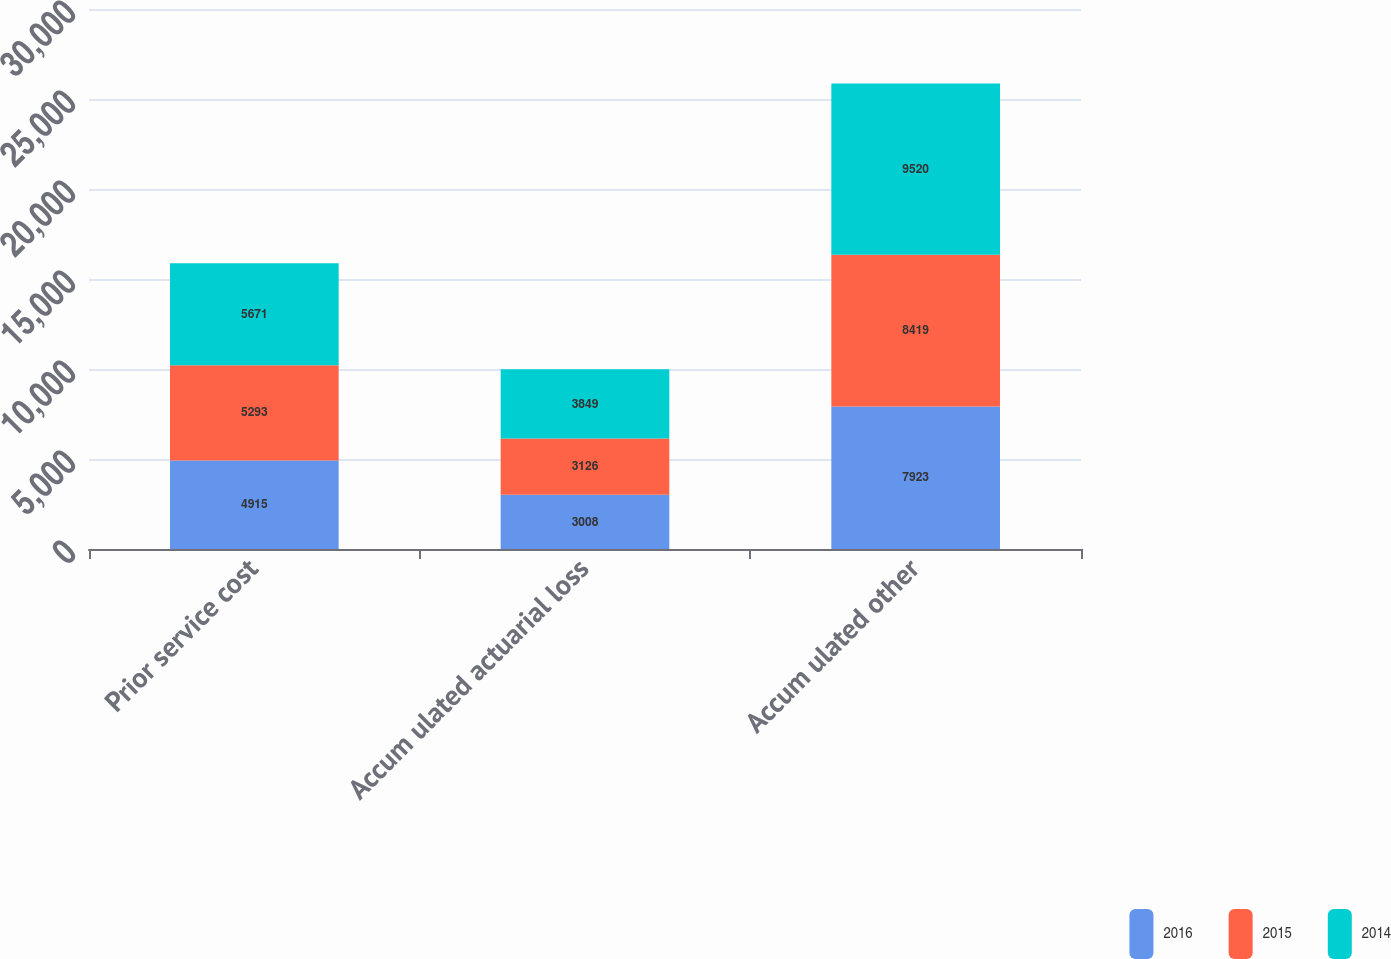<chart> <loc_0><loc_0><loc_500><loc_500><stacked_bar_chart><ecel><fcel>Prior service cost<fcel>Accum ulated actuarial loss<fcel>Accum ulated other<nl><fcel>2016<fcel>4915<fcel>3008<fcel>7923<nl><fcel>2015<fcel>5293<fcel>3126<fcel>8419<nl><fcel>2014<fcel>5671<fcel>3849<fcel>9520<nl></chart> 